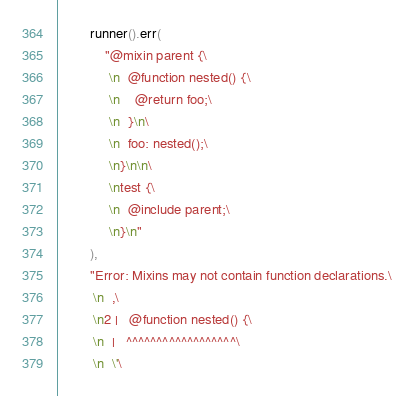<code> <loc_0><loc_0><loc_500><loc_500><_Rust_>        runner().err(
            "@mixin parent {\
             \n  @function nested() {\
             \n    @return foo;\
             \n  }\n\
             \n  foo: nested();\
             \n}\n\n\
             \ntest {\
             \n  @include parent;\
             \n}\n"
        ),
        "Error: Mixins may not contain function declarations.\
         \n  ,\
         \n2 |   @function nested() {\
         \n  |   ^^^^^^^^^^^^^^^^^^\
         \n  \'\</code> 